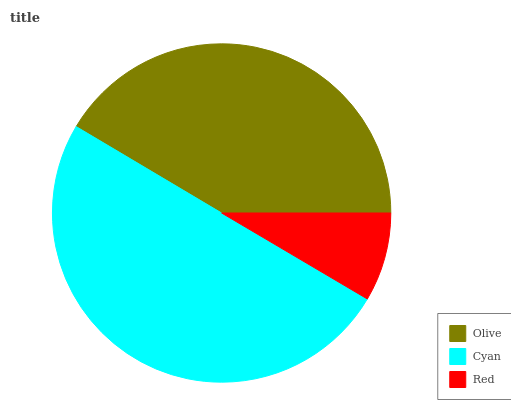Is Red the minimum?
Answer yes or no. Yes. Is Cyan the maximum?
Answer yes or no. Yes. Is Cyan the minimum?
Answer yes or no. No. Is Red the maximum?
Answer yes or no. No. Is Cyan greater than Red?
Answer yes or no. Yes. Is Red less than Cyan?
Answer yes or no. Yes. Is Red greater than Cyan?
Answer yes or no. No. Is Cyan less than Red?
Answer yes or no. No. Is Olive the high median?
Answer yes or no. Yes. Is Olive the low median?
Answer yes or no. Yes. Is Cyan the high median?
Answer yes or no. No. Is Cyan the low median?
Answer yes or no. No. 